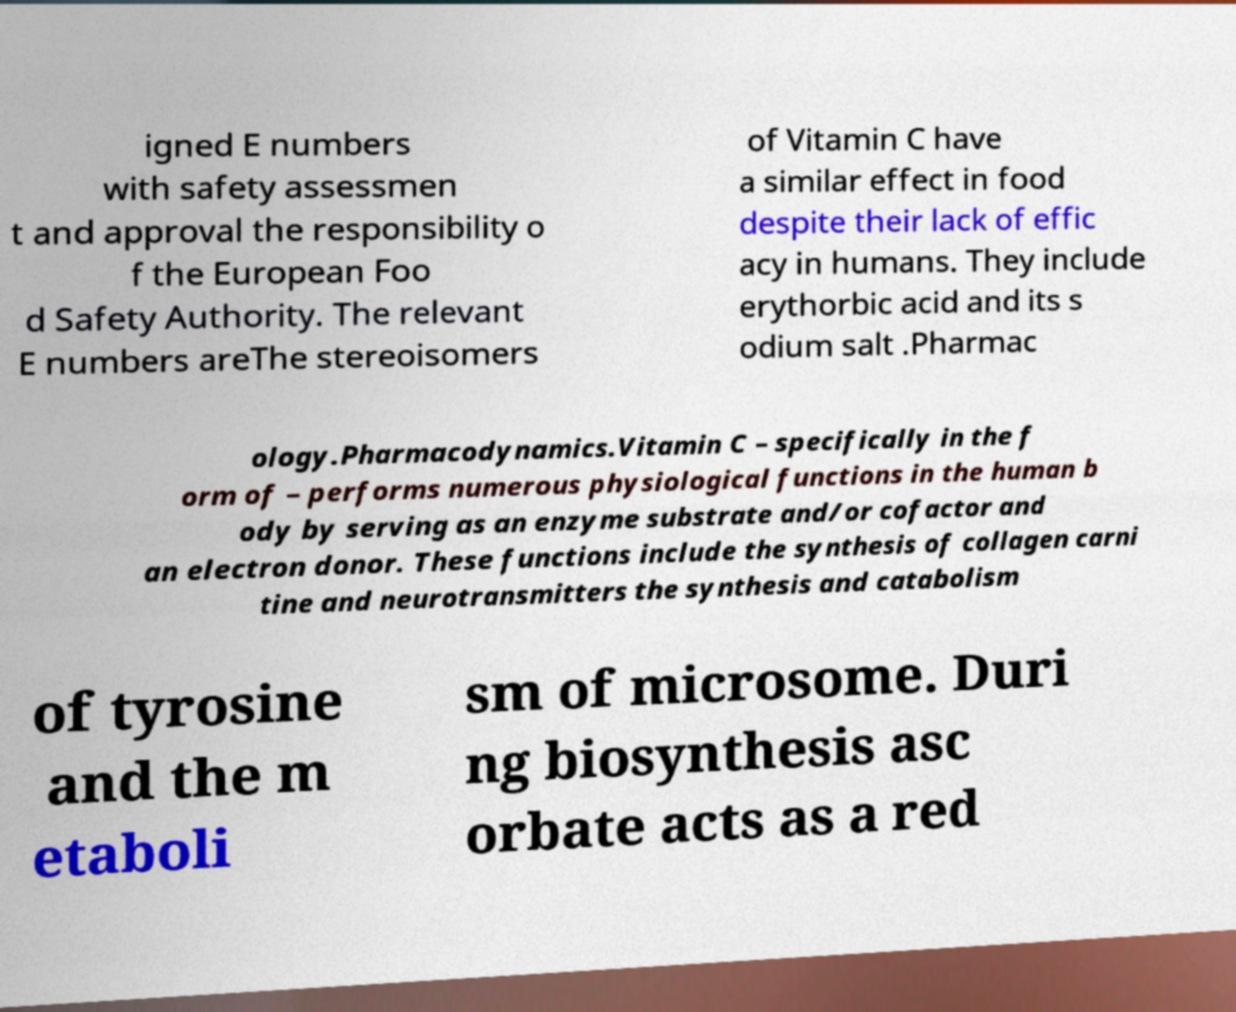Could you assist in decoding the text presented in this image and type it out clearly? igned E numbers with safety assessmen t and approval the responsibility o f the European Foo d Safety Authority. The relevant E numbers areThe stereoisomers of Vitamin C have a similar effect in food despite their lack of effic acy in humans. They include erythorbic acid and its s odium salt .Pharmac ology.Pharmacodynamics.Vitamin C – specifically in the f orm of – performs numerous physiological functions in the human b ody by serving as an enzyme substrate and/or cofactor and an electron donor. These functions include the synthesis of collagen carni tine and neurotransmitters the synthesis and catabolism of tyrosine and the m etaboli sm of microsome. Duri ng biosynthesis asc orbate acts as a red 